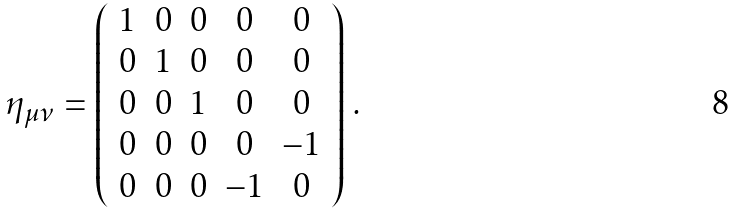Convert formula to latex. <formula><loc_0><loc_0><loc_500><loc_500>\eta _ { \mu \nu } = \left ( \begin{array} { c c c c c } 1 & 0 & 0 & 0 & 0 \\ 0 & 1 & 0 & 0 & 0 \\ 0 & 0 & 1 & 0 & 0 \\ 0 & 0 & 0 & 0 & - 1 \\ 0 & 0 & 0 & - 1 & 0 \\ \end{array} \right ) \, .</formula> 